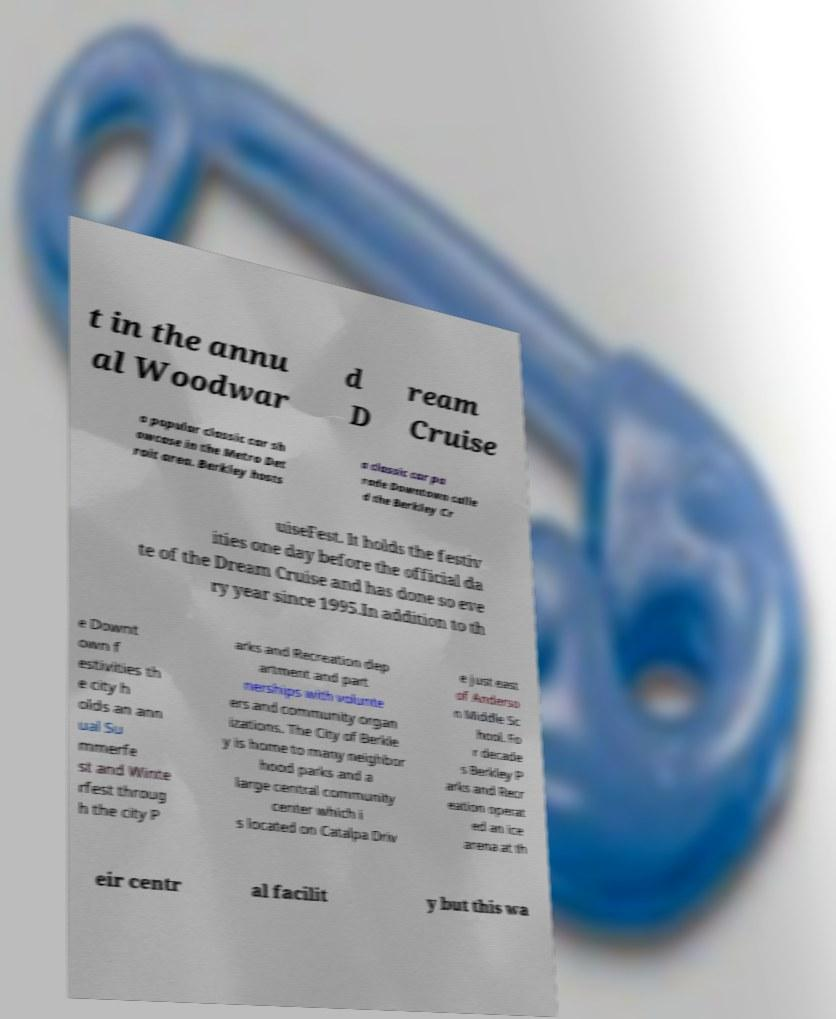Can you accurately transcribe the text from the provided image for me? t in the annu al Woodwar d D ream Cruise a popular classic car sh owcase in the Metro Det roit area. Berkley hosts a classic car pa rade Downtown calle d the Berkley Cr uiseFest. It holds the festiv ities one day before the official da te of the Dream Cruise and has done so eve ry year since 1995.In addition to th e Downt own f estivities th e city h olds an ann ual Su mmerfe st and Winte rfest throug h the city P arks and Recreation dep artment and part nerships with volunte ers and community organ izations. The City of Berkle y is home to many neighbor hood parks and a large central community center which i s located on Catalpa Driv e just east of Anderso n Middle Sc hool. Fo r decade s Berkley P arks and Recr eation operat ed an ice arena at th eir centr al facilit y but this wa 